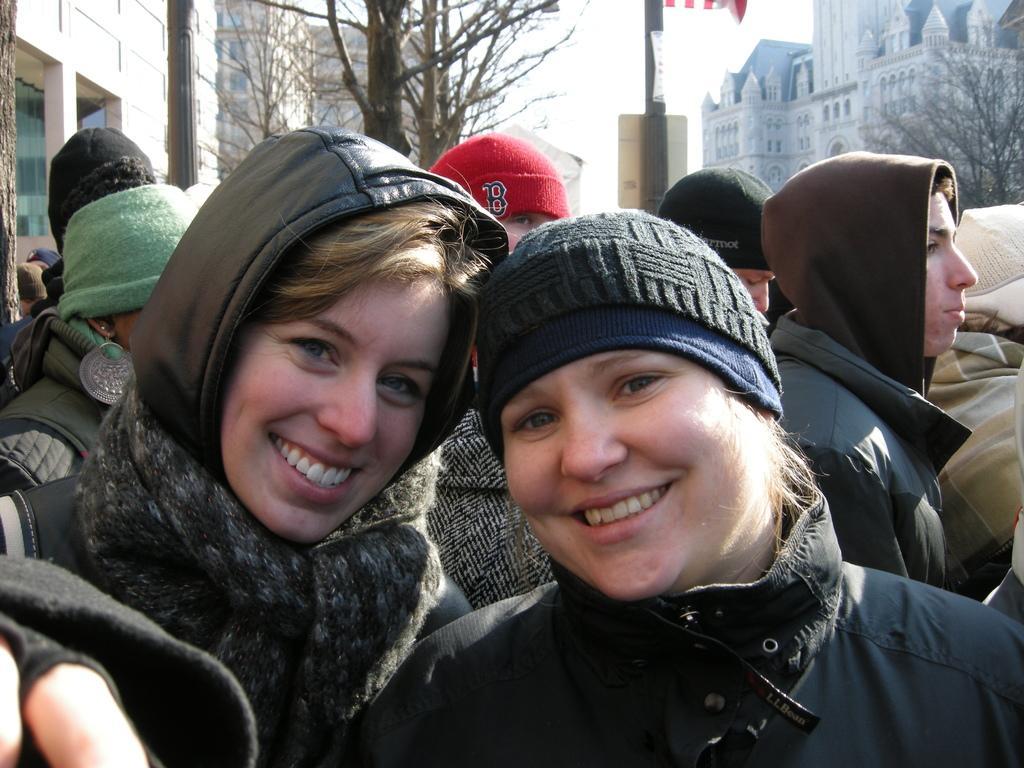Please provide a concise description of this image. In this image I can see number of people are standing. I can also see all of them are wearing jackets and caps. In the front side of the image I can see two persons are smiling and in the background I can see few trees, few poles, few buildings and the sky. I can also see a flag like thing on the top side of the image. 